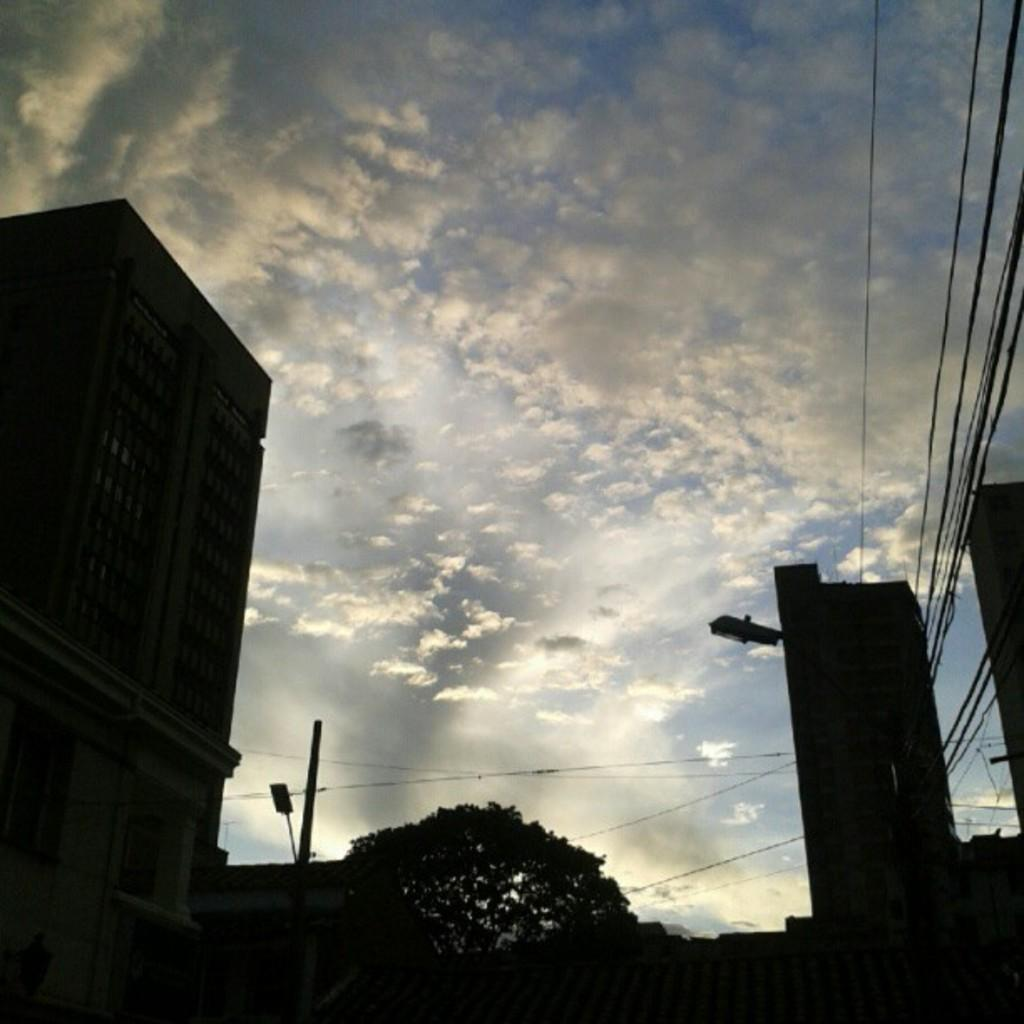What type of structures can be seen in the image? There are buildings in the image. What type of natural elements are present in the image? There are trees in the image. What type of man-made objects can be seen in the image? There are poles in the image. What else can be seen in the image that is related to the poles? There are wires in the image. What is the condition of the sky in the image? The sky is cloudy in the image. What type of vessel is visible on the shelf in the image? There is no vessel or shelf present in the image. What type of hearing device is visible on the poles in the image? There is no hearing device present in the image. 